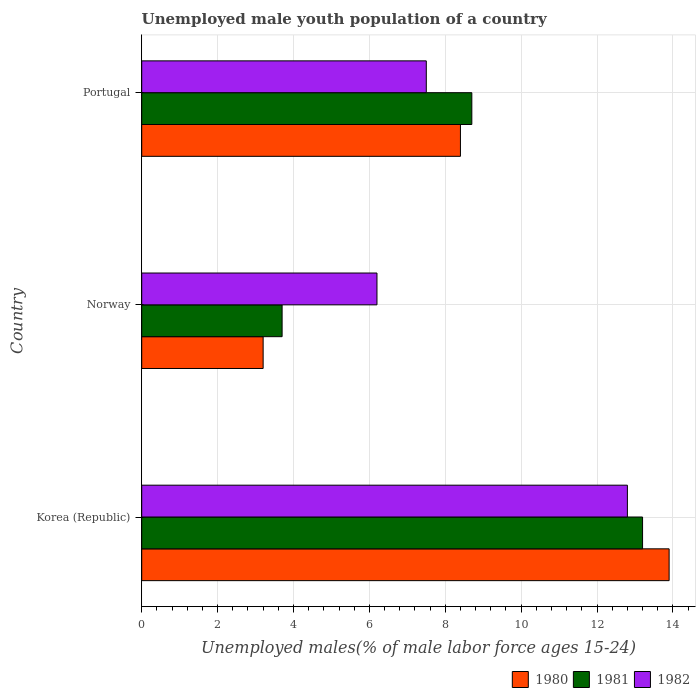How many different coloured bars are there?
Give a very brief answer. 3. Are the number of bars per tick equal to the number of legend labels?
Your answer should be very brief. Yes. How many bars are there on the 2nd tick from the bottom?
Make the answer very short. 3. What is the label of the 2nd group of bars from the top?
Provide a succinct answer. Norway. What is the percentage of unemployed male youth population in 1981 in Norway?
Keep it short and to the point. 3.7. Across all countries, what is the maximum percentage of unemployed male youth population in 1980?
Keep it short and to the point. 13.9. Across all countries, what is the minimum percentage of unemployed male youth population in 1980?
Your response must be concise. 3.2. What is the total percentage of unemployed male youth population in 1980 in the graph?
Your response must be concise. 25.5. What is the difference between the percentage of unemployed male youth population in 1980 in Korea (Republic) and that in Norway?
Ensure brevity in your answer.  10.7. What is the difference between the percentage of unemployed male youth population in 1982 in Korea (Republic) and the percentage of unemployed male youth population in 1981 in Portugal?
Your answer should be compact. 4.1. What is the average percentage of unemployed male youth population in 1981 per country?
Make the answer very short. 8.53. What is the difference between the percentage of unemployed male youth population in 1980 and percentage of unemployed male youth population in 1982 in Portugal?
Make the answer very short. 0.9. In how many countries, is the percentage of unemployed male youth population in 1982 greater than 10.8 %?
Provide a short and direct response. 1. What is the ratio of the percentage of unemployed male youth population in 1980 in Norway to that in Portugal?
Your answer should be very brief. 0.38. Is the percentage of unemployed male youth population in 1981 in Korea (Republic) less than that in Norway?
Keep it short and to the point. No. Is the difference between the percentage of unemployed male youth population in 1980 in Korea (Republic) and Norway greater than the difference between the percentage of unemployed male youth population in 1982 in Korea (Republic) and Norway?
Make the answer very short. Yes. What is the difference between the highest and the second highest percentage of unemployed male youth population in 1981?
Your response must be concise. 4.5. What is the difference between the highest and the lowest percentage of unemployed male youth population in 1981?
Your response must be concise. 9.5. Is the sum of the percentage of unemployed male youth population in 1982 in Korea (Republic) and Portugal greater than the maximum percentage of unemployed male youth population in 1980 across all countries?
Your answer should be very brief. Yes. Is it the case that in every country, the sum of the percentage of unemployed male youth population in 1981 and percentage of unemployed male youth population in 1980 is greater than the percentage of unemployed male youth population in 1982?
Your response must be concise. Yes. How many countries are there in the graph?
Your response must be concise. 3. Does the graph contain grids?
Ensure brevity in your answer.  Yes. Where does the legend appear in the graph?
Provide a succinct answer. Bottom right. What is the title of the graph?
Make the answer very short. Unemployed male youth population of a country. What is the label or title of the X-axis?
Make the answer very short. Unemployed males(% of male labor force ages 15-24). What is the label or title of the Y-axis?
Make the answer very short. Country. What is the Unemployed males(% of male labor force ages 15-24) of 1980 in Korea (Republic)?
Provide a succinct answer. 13.9. What is the Unemployed males(% of male labor force ages 15-24) of 1981 in Korea (Republic)?
Your response must be concise. 13.2. What is the Unemployed males(% of male labor force ages 15-24) of 1982 in Korea (Republic)?
Ensure brevity in your answer.  12.8. What is the Unemployed males(% of male labor force ages 15-24) of 1980 in Norway?
Provide a succinct answer. 3.2. What is the Unemployed males(% of male labor force ages 15-24) in 1981 in Norway?
Ensure brevity in your answer.  3.7. What is the Unemployed males(% of male labor force ages 15-24) of 1982 in Norway?
Offer a very short reply. 6.2. What is the Unemployed males(% of male labor force ages 15-24) in 1980 in Portugal?
Provide a short and direct response. 8.4. What is the Unemployed males(% of male labor force ages 15-24) of 1981 in Portugal?
Offer a terse response. 8.7. Across all countries, what is the maximum Unemployed males(% of male labor force ages 15-24) in 1980?
Offer a terse response. 13.9. Across all countries, what is the maximum Unemployed males(% of male labor force ages 15-24) of 1981?
Your answer should be compact. 13.2. Across all countries, what is the maximum Unemployed males(% of male labor force ages 15-24) in 1982?
Give a very brief answer. 12.8. Across all countries, what is the minimum Unemployed males(% of male labor force ages 15-24) of 1980?
Keep it short and to the point. 3.2. Across all countries, what is the minimum Unemployed males(% of male labor force ages 15-24) in 1981?
Keep it short and to the point. 3.7. Across all countries, what is the minimum Unemployed males(% of male labor force ages 15-24) of 1982?
Give a very brief answer. 6.2. What is the total Unemployed males(% of male labor force ages 15-24) in 1981 in the graph?
Ensure brevity in your answer.  25.6. What is the difference between the Unemployed males(% of male labor force ages 15-24) in 1981 in Korea (Republic) and that in Norway?
Ensure brevity in your answer.  9.5. What is the difference between the Unemployed males(% of male labor force ages 15-24) of 1980 in Korea (Republic) and that in Portugal?
Ensure brevity in your answer.  5.5. What is the difference between the Unemployed males(% of male labor force ages 15-24) in 1982 in Korea (Republic) and that in Portugal?
Your answer should be very brief. 5.3. What is the difference between the Unemployed males(% of male labor force ages 15-24) in 1980 in Norway and that in Portugal?
Provide a succinct answer. -5.2. What is the difference between the Unemployed males(% of male labor force ages 15-24) of 1980 in Korea (Republic) and the Unemployed males(% of male labor force ages 15-24) of 1981 in Norway?
Offer a terse response. 10.2. What is the difference between the Unemployed males(% of male labor force ages 15-24) of 1981 in Korea (Republic) and the Unemployed males(% of male labor force ages 15-24) of 1982 in Norway?
Your response must be concise. 7. What is the difference between the Unemployed males(% of male labor force ages 15-24) of 1980 in Korea (Republic) and the Unemployed males(% of male labor force ages 15-24) of 1982 in Portugal?
Provide a succinct answer. 6.4. What is the difference between the Unemployed males(% of male labor force ages 15-24) in 1981 in Korea (Republic) and the Unemployed males(% of male labor force ages 15-24) in 1982 in Portugal?
Provide a short and direct response. 5.7. What is the difference between the Unemployed males(% of male labor force ages 15-24) of 1981 in Norway and the Unemployed males(% of male labor force ages 15-24) of 1982 in Portugal?
Keep it short and to the point. -3.8. What is the average Unemployed males(% of male labor force ages 15-24) of 1980 per country?
Offer a terse response. 8.5. What is the average Unemployed males(% of male labor force ages 15-24) of 1981 per country?
Offer a terse response. 8.53. What is the average Unemployed males(% of male labor force ages 15-24) in 1982 per country?
Your answer should be very brief. 8.83. What is the difference between the Unemployed males(% of male labor force ages 15-24) of 1980 and Unemployed males(% of male labor force ages 15-24) of 1982 in Korea (Republic)?
Give a very brief answer. 1.1. What is the difference between the Unemployed males(% of male labor force ages 15-24) in 1981 and Unemployed males(% of male labor force ages 15-24) in 1982 in Korea (Republic)?
Make the answer very short. 0.4. What is the difference between the Unemployed males(% of male labor force ages 15-24) in 1981 and Unemployed males(% of male labor force ages 15-24) in 1982 in Norway?
Keep it short and to the point. -2.5. What is the difference between the Unemployed males(% of male labor force ages 15-24) in 1980 and Unemployed males(% of male labor force ages 15-24) in 1981 in Portugal?
Your answer should be very brief. -0.3. What is the difference between the Unemployed males(% of male labor force ages 15-24) in 1980 and Unemployed males(% of male labor force ages 15-24) in 1982 in Portugal?
Offer a terse response. 0.9. What is the ratio of the Unemployed males(% of male labor force ages 15-24) of 1980 in Korea (Republic) to that in Norway?
Your response must be concise. 4.34. What is the ratio of the Unemployed males(% of male labor force ages 15-24) of 1981 in Korea (Republic) to that in Norway?
Provide a short and direct response. 3.57. What is the ratio of the Unemployed males(% of male labor force ages 15-24) of 1982 in Korea (Republic) to that in Norway?
Ensure brevity in your answer.  2.06. What is the ratio of the Unemployed males(% of male labor force ages 15-24) in 1980 in Korea (Republic) to that in Portugal?
Give a very brief answer. 1.65. What is the ratio of the Unemployed males(% of male labor force ages 15-24) in 1981 in Korea (Republic) to that in Portugal?
Give a very brief answer. 1.52. What is the ratio of the Unemployed males(% of male labor force ages 15-24) of 1982 in Korea (Republic) to that in Portugal?
Ensure brevity in your answer.  1.71. What is the ratio of the Unemployed males(% of male labor force ages 15-24) of 1980 in Norway to that in Portugal?
Your answer should be compact. 0.38. What is the ratio of the Unemployed males(% of male labor force ages 15-24) of 1981 in Norway to that in Portugal?
Provide a succinct answer. 0.43. What is the ratio of the Unemployed males(% of male labor force ages 15-24) in 1982 in Norway to that in Portugal?
Offer a very short reply. 0.83. What is the difference between the highest and the second highest Unemployed males(% of male labor force ages 15-24) in 1980?
Your answer should be very brief. 5.5. What is the difference between the highest and the lowest Unemployed males(% of male labor force ages 15-24) in 1980?
Keep it short and to the point. 10.7. What is the difference between the highest and the lowest Unemployed males(% of male labor force ages 15-24) in 1981?
Offer a terse response. 9.5. 